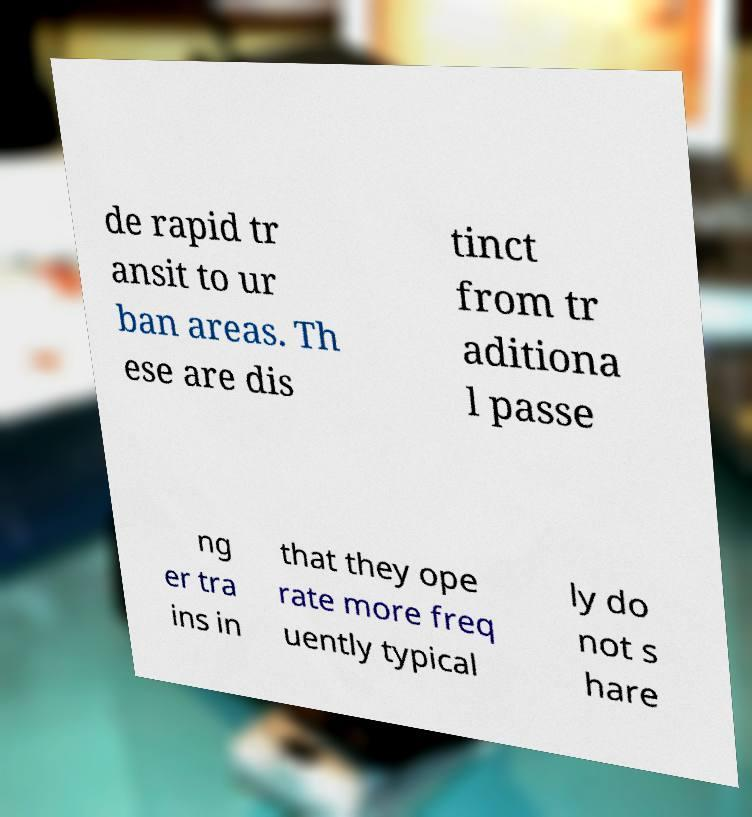Can you read and provide the text displayed in the image?This photo seems to have some interesting text. Can you extract and type it out for me? de rapid tr ansit to ur ban areas. Th ese are dis tinct from tr aditiona l passe ng er tra ins in that they ope rate more freq uently typical ly do not s hare 